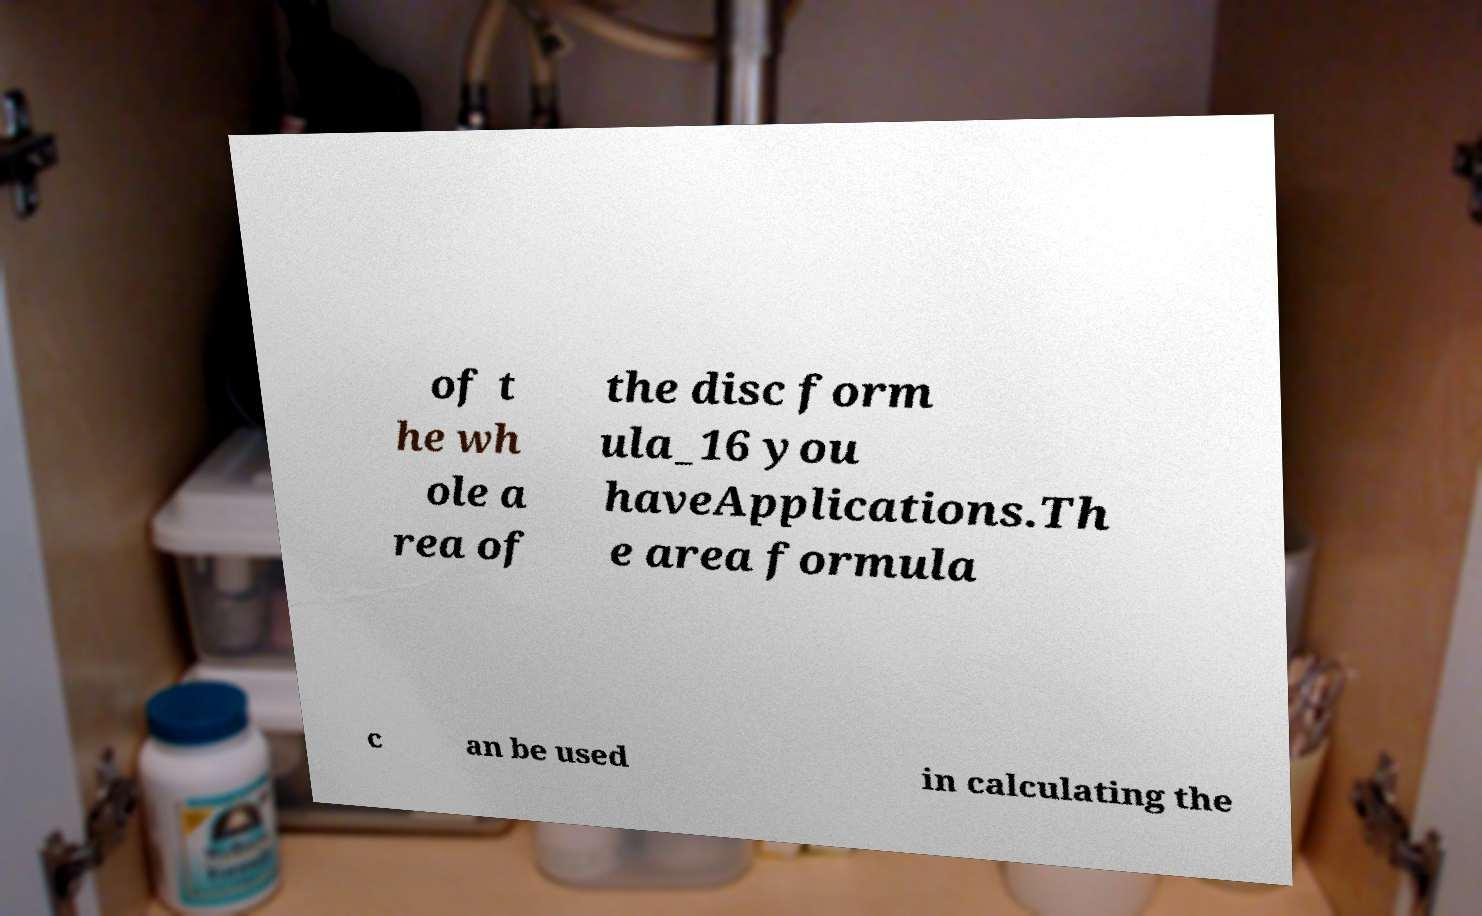There's text embedded in this image that I need extracted. Can you transcribe it verbatim? of t he wh ole a rea of the disc form ula_16 you haveApplications.Th e area formula c an be used in calculating the 